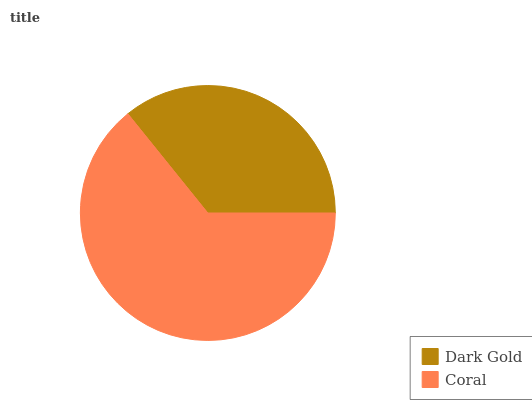Is Dark Gold the minimum?
Answer yes or no. Yes. Is Coral the maximum?
Answer yes or no. Yes. Is Coral the minimum?
Answer yes or no. No. Is Coral greater than Dark Gold?
Answer yes or no. Yes. Is Dark Gold less than Coral?
Answer yes or no. Yes. Is Dark Gold greater than Coral?
Answer yes or no. No. Is Coral less than Dark Gold?
Answer yes or no. No. Is Coral the high median?
Answer yes or no. Yes. Is Dark Gold the low median?
Answer yes or no. Yes. Is Dark Gold the high median?
Answer yes or no. No. Is Coral the low median?
Answer yes or no. No. 